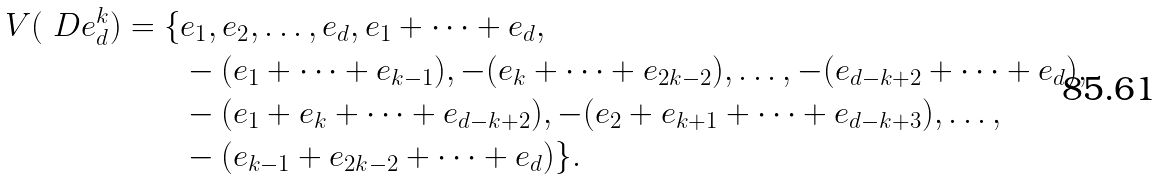Convert formula to latex. <formula><loc_0><loc_0><loc_500><loc_500>V ( \ D e ^ { k } _ { d } ) = \{ & e _ { 1 } , e _ { 2 } , \dots , e _ { d } , e _ { 1 } + \dots + e _ { d } , \\ & - ( e _ { 1 } + \dots + e _ { k - 1 } ) , - ( e _ { k } + \dots + e _ { 2 k - 2 } ) , \dots , - ( e _ { d - k + 2 } + \dots + e _ { d } ) , \\ & - ( e _ { 1 } + e _ { k } + \dots + e _ { d - k + 2 } ) , - ( e _ { 2 } + e _ { k + 1 } + \dots + e _ { d - k + 3 } ) , \dots , \\ & - ( e _ { k - 1 } + e _ { 2 k - 2 } + \dots + e _ { d } ) \} .</formula> 